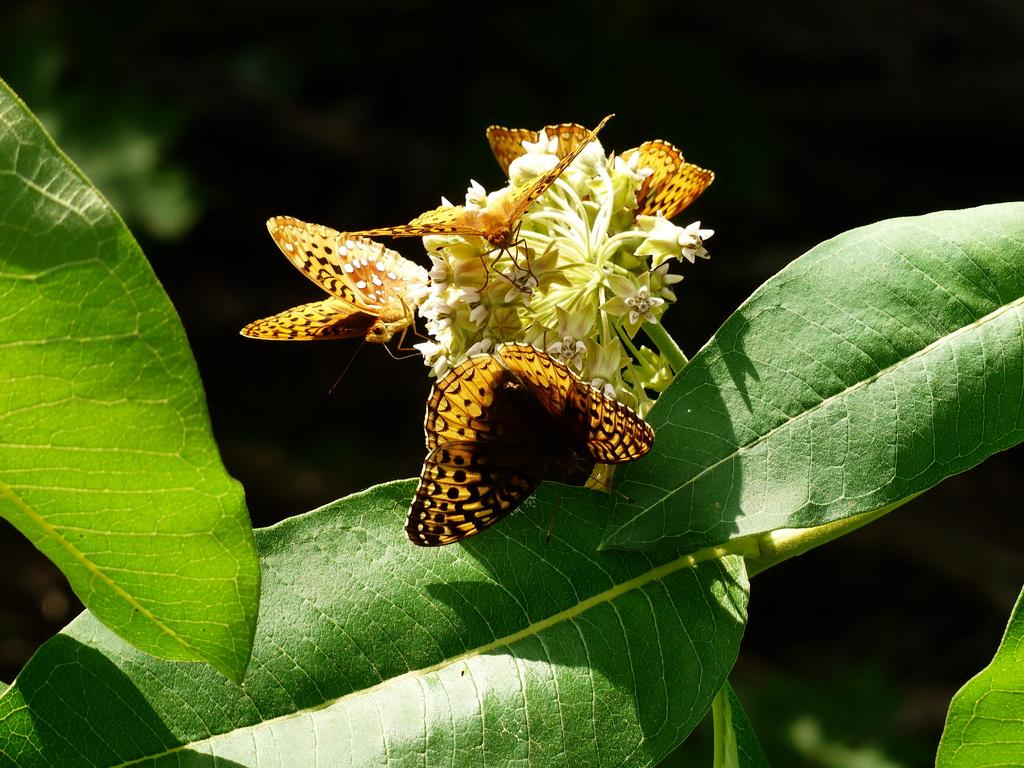What type of animals can be seen in the image? There are butterflies in the image. Where are the butterflies located in the image? The butterflies are on flowers and leaves. What type of division is taking place in the image? There is no division present in the image; it features butterflies on flowers and leaves. Can you tell me how many roses are in the image? There is no rose mentioned in the image; it only features butterflies on flowers and leaves. 